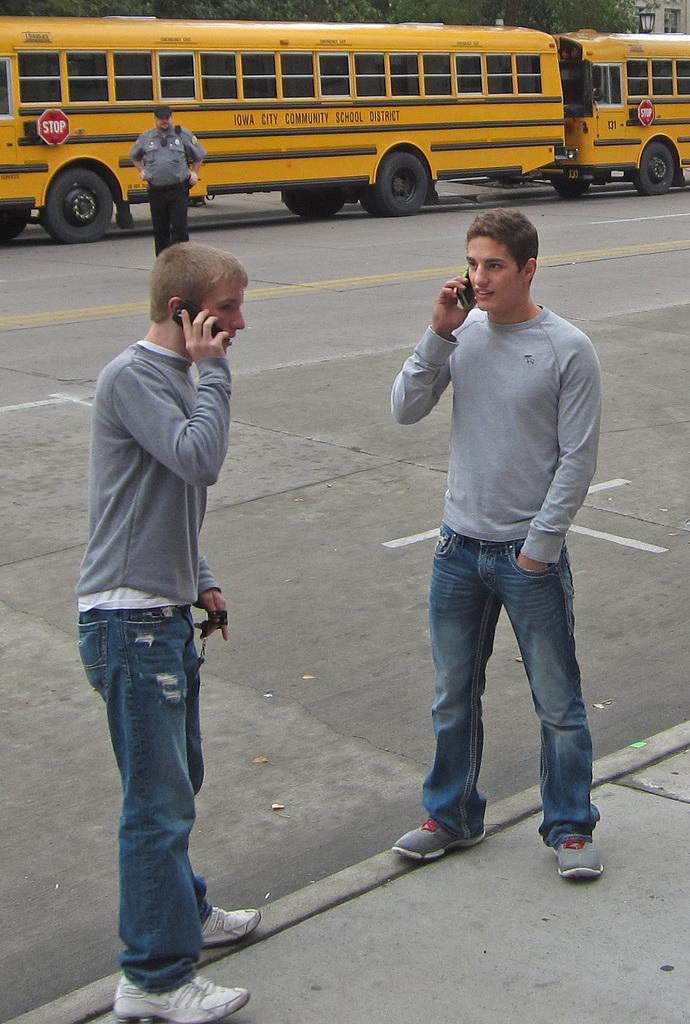Could you give a brief overview of what you see in this image? In this image we can see three persons, among them, two persons are holding the mobile phones, there are vehicles, trees, light and a building. 